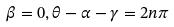Convert formula to latex. <formula><loc_0><loc_0><loc_500><loc_500>\beta = 0 , \theta - \alpha - \gamma = 2 n \pi</formula> 